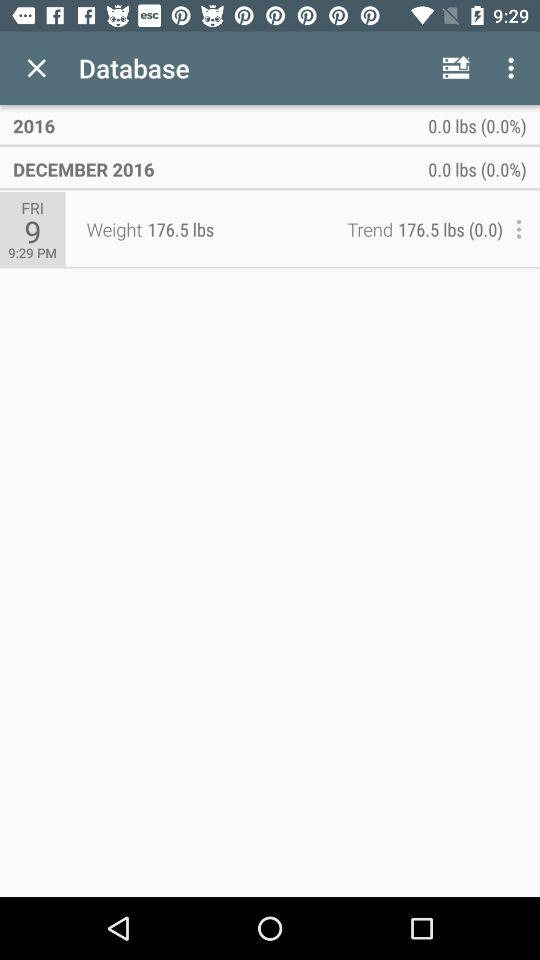What is the date on which the weight was measured? The weight was measured on Friday, December 9, 2016. 